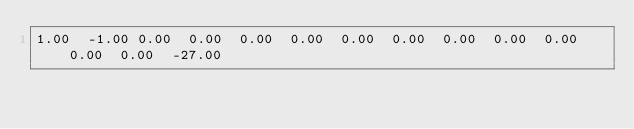<code> <loc_0><loc_0><loc_500><loc_500><_Matlab_>1.00	-1.00	0.00	0.00	0.00	0.00	0.00	0.00	0.00	0.00	0.00	0.00	0.00	-27.00</code> 